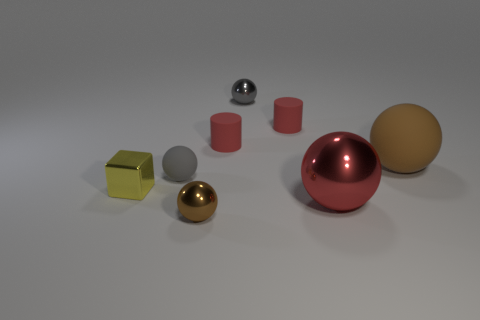What materials are represented by the objects in the image? The objects seem to represent materials such as polished metal, matte metal, and plastic, each having distinct textures and reflective properties. 